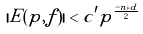<formula> <loc_0><loc_0><loc_500><loc_500>| E ( p , f ) | < c ^ { \prime } p ^ { \frac { - n + d } { 2 } }</formula> 